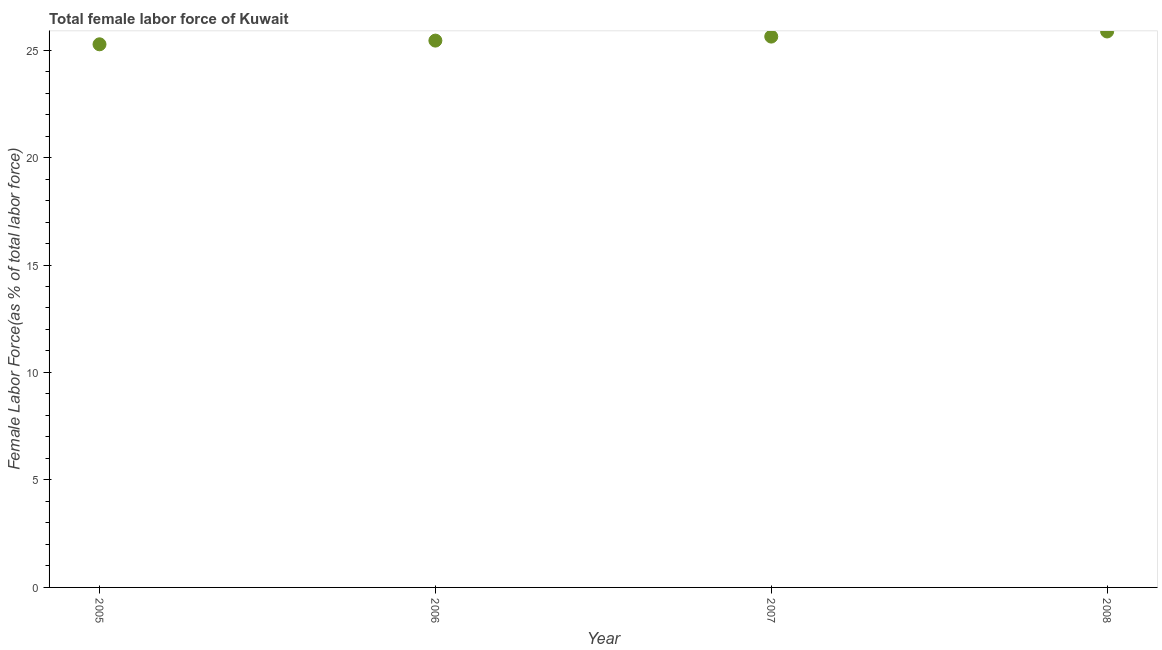What is the total female labor force in 2007?
Offer a terse response. 25.63. Across all years, what is the maximum total female labor force?
Your answer should be very brief. 25.86. Across all years, what is the minimum total female labor force?
Make the answer very short. 25.27. In which year was the total female labor force maximum?
Ensure brevity in your answer.  2008. What is the sum of the total female labor force?
Keep it short and to the point. 102.2. What is the difference between the total female labor force in 2005 and 2006?
Offer a very short reply. -0.17. What is the average total female labor force per year?
Make the answer very short. 25.55. What is the median total female labor force?
Ensure brevity in your answer.  25.53. Do a majority of the years between 2007 and 2006 (inclusive) have total female labor force greater than 17 %?
Provide a short and direct response. No. What is the ratio of the total female labor force in 2006 to that in 2008?
Provide a short and direct response. 0.98. Is the total female labor force in 2006 less than that in 2008?
Offer a terse response. Yes. Is the difference between the total female labor force in 2005 and 2006 greater than the difference between any two years?
Your answer should be compact. No. What is the difference between the highest and the second highest total female labor force?
Provide a succinct answer. 0.24. What is the difference between the highest and the lowest total female labor force?
Ensure brevity in your answer.  0.6. How many years are there in the graph?
Provide a succinct answer. 4. Are the values on the major ticks of Y-axis written in scientific E-notation?
Your response must be concise. No. Does the graph contain grids?
Offer a terse response. No. What is the title of the graph?
Offer a very short reply. Total female labor force of Kuwait. What is the label or title of the X-axis?
Offer a very short reply. Year. What is the label or title of the Y-axis?
Your answer should be compact. Female Labor Force(as % of total labor force). What is the Female Labor Force(as % of total labor force) in 2005?
Provide a succinct answer. 25.27. What is the Female Labor Force(as % of total labor force) in 2006?
Give a very brief answer. 25.44. What is the Female Labor Force(as % of total labor force) in 2007?
Keep it short and to the point. 25.63. What is the Female Labor Force(as % of total labor force) in 2008?
Offer a very short reply. 25.86. What is the difference between the Female Labor Force(as % of total labor force) in 2005 and 2006?
Make the answer very short. -0.17. What is the difference between the Female Labor Force(as % of total labor force) in 2005 and 2007?
Offer a very short reply. -0.36. What is the difference between the Female Labor Force(as % of total labor force) in 2005 and 2008?
Ensure brevity in your answer.  -0.6. What is the difference between the Female Labor Force(as % of total labor force) in 2006 and 2007?
Provide a short and direct response. -0.19. What is the difference between the Female Labor Force(as % of total labor force) in 2006 and 2008?
Your answer should be very brief. -0.42. What is the difference between the Female Labor Force(as % of total labor force) in 2007 and 2008?
Your answer should be compact. -0.24. What is the ratio of the Female Labor Force(as % of total labor force) in 2005 to that in 2007?
Your answer should be compact. 0.99. What is the ratio of the Female Labor Force(as % of total labor force) in 2005 to that in 2008?
Your answer should be compact. 0.98. What is the ratio of the Female Labor Force(as % of total labor force) in 2006 to that in 2008?
Your answer should be very brief. 0.98. 